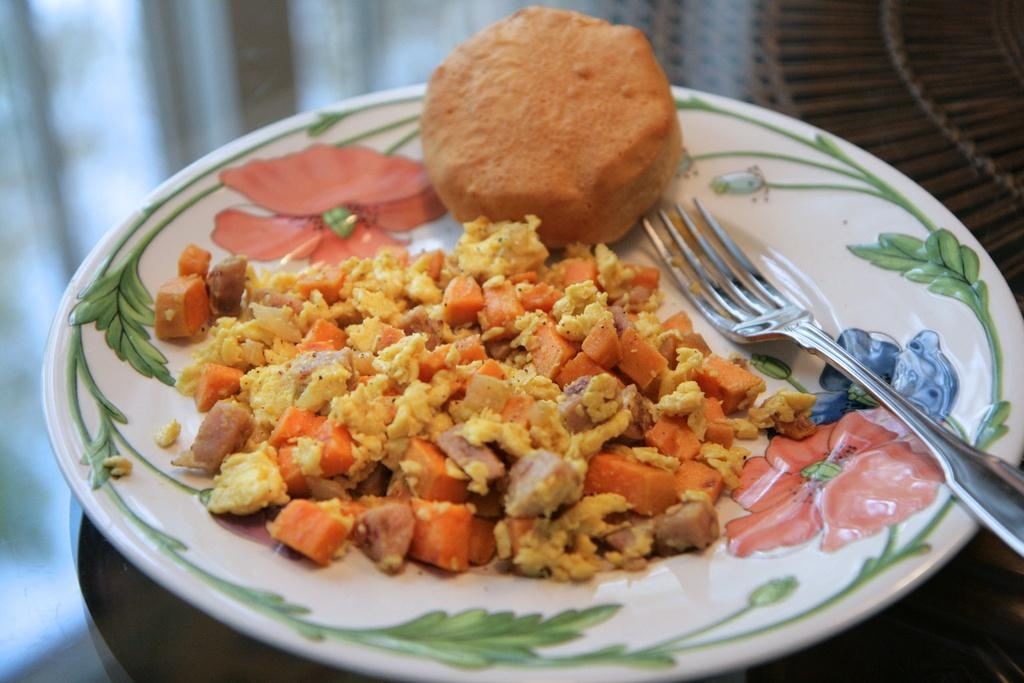What is present in the image that people typically eat? There is food in the image. What utensil can be seen on a plate in the image? There is a fork on a floral plate in the image. What piece of furniture is at the bottom of the image? There is a table at the bottom of the image. What force is being applied to the food by the stranger in the image? There is no stranger present in the image, so no force is being applied to the food by a stranger. 